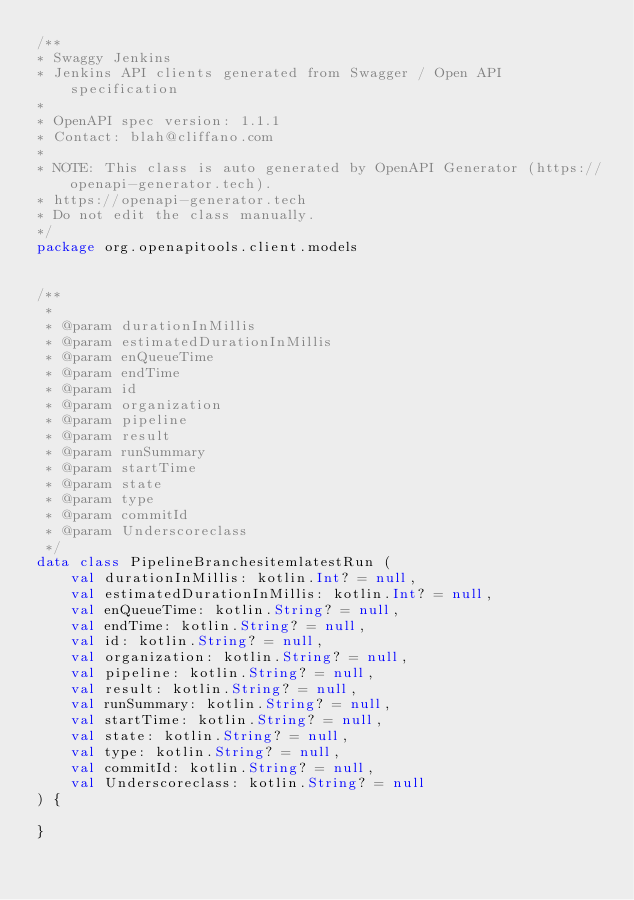Convert code to text. <code><loc_0><loc_0><loc_500><loc_500><_Kotlin_>/**
* Swaggy Jenkins
* Jenkins API clients generated from Swagger / Open API specification
*
* OpenAPI spec version: 1.1.1
* Contact: blah@cliffano.com
*
* NOTE: This class is auto generated by OpenAPI Generator (https://openapi-generator.tech).
* https://openapi-generator.tech
* Do not edit the class manually.
*/
package org.openapitools.client.models


/**
 * 
 * @param durationInMillis 
 * @param estimatedDurationInMillis 
 * @param enQueueTime 
 * @param endTime 
 * @param id 
 * @param organization 
 * @param pipeline 
 * @param result 
 * @param runSummary 
 * @param startTime 
 * @param state 
 * @param type 
 * @param commitId 
 * @param Underscoreclass 
 */
data class PipelineBranchesitemlatestRun (
    val durationInMillis: kotlin.Int? = null,
    val estimatedDurationInMillis: kotlin.Int? = null,
    val enQueueTime: kotlin.String? = null,
    val endTime: kotlin.String? = null,
    val id: kotlin.String? = null,
    val organization: kotlin.String? = null,
    val pipeline: kotlin.String? = null,
    val result: kotlin.String? = null,
    val runSummary: kotlin.String? = null,
    val startTime: kotlin.String? = null,
    val state: kotlin.String? = null,
    val type: kotlin.String? = null,
    val commitId: kotlin.String? = null,
    val Underscoreclass: kotlin.String? = null
) {

}

</code> 